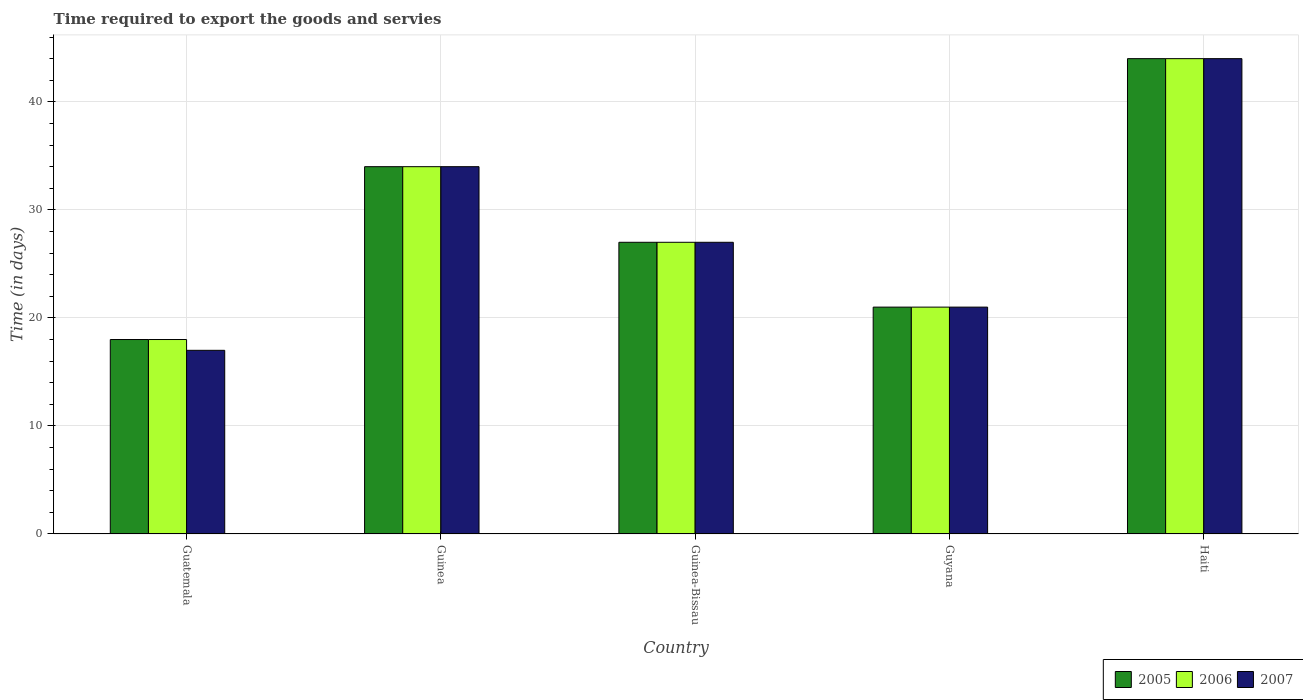How many different coloured bars are there?
Provide a succinct answer. 3. Are the number of bars on each tick of the X-axis equal?
Ensure brevity in your answer.  Yes. How many bars are there on the 1st tick from the left?
Ensure brevity in your answer.  3. What is the label of the 2nd group of bars from the left?
Keep it short and to the point. Guinea. In how many cases, is the number of bars for a given country not equal to the number of legend labels?
Give a very brief answer. 0. What is the number of days required to export the goods and services in 2007 in Guatemala?
Make the answer very short. 17. In which country was the number of days required to export the goods and services in 2007 maximum?
Your answer should be very brief. Haiti. In which country was the number of days required to export the goods and services in 2005 minimum?
Your answer should be compact. Guatemala. What is the total number of days required to export the goods and services in 2005 in the graph?
Offer a terse response. 144. What is the average number of days required to export the goods and services in 2007 per country?
Ensure brevity in your answer.  28.6. What is the difference between the number of days required to export the goods and services of/in 2007 and number of days required to export the goods and services of/in 2006 in Haiti?
Keep it short and to the point. 0. What is the ratio of the number of days required to export the goods and services in 2007 in Guatemala to that in Guyana?
Keep it short and to the point. 0.81. Is the number of days required to export the goods and services in 2007 in Guatemala less than that in Guyana?
Your response must be concise. Yes. Is the difference between the number of days required to export the goods and services in 2007 in Guatemala and Guyana greater than the difference between the number of days required to export the goods and services in 2006 in Guatemala and Guyana?
Offer a very short reply. No. What is the difference between the highest and the second highest number of days required to export the goods and services in 2005?
Offer a very short reply. 7. What is the difference between the highest and the lowest number of days required to export the goods and services in 2006?
Offer a very short reply. 26. In how many countries, is the number of days required to export the goods and services in 2006 greater than the average number of days required to export the goods and services in 2006 taken over all countries?
Ensure brevity in your answer.  2. Is the sum of the number of days required to export the goods and services in 2005 in Guinea and Guyana greater than the maximum number of days required to export the goods and services in 2007 across all countries?
Keep it short and to the point. Yes. Is it the case that in every country, the sum of the number of days required to export the goods and services in 2006 and number of days required to export the goods and services in 2005 is greater than the number of days required to export the goods and services in 2007?
Your response must be concise. Yes. Are all the bars in the graph horizontal?
Your response must be concise. No. Are the values on the major ticks of Y-axis written in scientific E-notation?
Keep it short and to the point. No. Where does the legend appear in the graph?
Your answer should be compact. Bottom right. What is the title of the graph?
Provide a succinct answer. Time required to export the goods and servies. What is the label or title of the X-axis?
Offer a very short reply. Country. What is the label or title of the Y-axis?
Give a very brief answer. Time (in days). What is the Time (in days) in 2006 in Guatemala?
Offer a very short reply. 18. What is the Time (in days) in 2006 in Guinea-Bissau?
Your answer should be compact. 27. What is the Time (in days) of 2007 in Guinea-Bissau?
Offer a very short reply. 27. What is the Time (in days) of 2005 in Guyana?
Your answer should be compact. 21. What is the Time (in days) of 2006 in Guyana?
Keep it short and to the point. 21. Across all countries, what is the maximum Time (in days) of 2005?
Offer a terse response. 44. Across all countries, what is the maximum Time (in days) of 2006?
Keep it short and to the point. 44. Across all countries, what is the minimum Time (in days) in 2007?
Your response must be concise. 17. What is the total Time (in days) of 2005 in the graph?
Provide a succinct answer. 144. What is the total Time (in days) of 2006 in the graph?
Provide a succinct answer. 144. What is the total Time (in days) of 2007 in the graph?
Provide a short and direct response. 143. What is the difference between the Time (in days) in 2006 in Guatemala and that in Guinea?
Your response must be concise. -16. What is the difference between the Time (in days) of 2006 in Guatemala and that in Guinea-Bissau?
Offer a terse response. -9. What is the difference between the Time (in days) of 2007 in Guatemala and that in Guinea-Bissau?
Provide a succinct answer. -10. What is the difference between the Time (in days) in 2005 in Guatemala and that in Guyana?
Your answer should be compact. -3. What is the difference between the Time (in days) of 2006 in Guatemala and that in Guyana?
Your response must be concise. -3. What is the difference between the Time (in days) in 2006 in Guatemala and that in Haiti?
Provide a succinct answer. -26. What is the difference between the Time (in days) in 2007 in Guatemala and that in Haiti?
Your answer should be very brief. -27. What is the difference between the Time (in days) in 2007 in Guinea and that in Guinea-Bissau?
Ensure brevity in your answer.  7. What is the difference between the Time (in days) of 2006 in Guinea and that in Guyana?
Keep it short and to the point. 13. What is the difference between the Time (in days) of 2006 in Guinea and that in Haiti?
Provide a succinct answer. -10. What is the difference between the Time (in days) in 2007 in Guinea and that in Haiti?
Ensure brevity in your answer.  -10. What is the difference between the Time (in days) of 2005 in Guyana and that in Haiti?
Your response must be concise. -23. What is the difference between the Time (in days) in 2007 in Guyana and that in Haiti?
Make the answer very short. -23. What is the difference between the Time (in days) of 2005 in Guatemala and the Time (in days) of 2006 in Guinea-Bissau?
Your response must be concise. -9. What is the difference between the Time (in days) in 2005 in Guatemala and the Time (in days) in 2007 in Guinea-Bissau?
Your response must be concise. -9. What is the difference between the Time (in days) in 2006 in Guatemala and the Time (in days) in 2007 in Guinea-Bissau?
Ensure brevity in your answer.  -9. What is the difference between the Time (in days) of 2005 in Guatemala and the Time (in days) of 2007 in Guyana?
Make the answer very short. -3. What is the difference between the Time (in days) in 2006 in Guatemala and the Time (in days) in 2007 in Guyana?
Your answer should be very brief. -3. What is the difference between the Time (in days) of 2005 in Guatemala and the Time (in days) of 2006 in Haiti?
Your response must be concise. -26. What is the difference between the Time (in days) in 2005 in Guatemala and the Time (in days) in 2007 in Haiti?
Keep it short and to the point. -26. What is the difference between the Time (in days) of 2006 in Guatemala and the Time (in days) of 2007 in Haiti?
Provide a succinct answer. -26. What is the difference between the Time (in days) of 2006 in Guinea and the Time (in days) of 2007 in Guyana?
Offer a very short reply. 13. What is the difference between the Time (in days) in 2005 in Guinea and the Time (in days) in 2006 in Haiti?
Ensure brevity in your answer.  -10. What is the difference between the Time (in days) of 2005 in Guinea-Bissau and the Time (in days) of 2007 in Guyana?
Ensure brevity in your answer.  6. What is the difference between the Time (in days) of 2005 in Guinea-Bissau and the Time (in days) of 2006 in Haiti?
Make the answer very short. -17. What is the average Time (in days) of 2005 per country?
Provide a short and direct response. 28.8. What is the average Time (in days) of 2006 per country?
Keep it short and to the point. 28.8. What is the average Time (in days) of 2007 per country?
Offer a terse response. 28.6. What is the difference between the Time (in days) in 2005 and Time (in days) in 2006 in Guinea?
Make the answer very short. 0. What is the difference between the Time (in days) of 2006 and Time (in days) of 2007 in Guinea?
Keep it short and to the point. 0. What is the difference between the Time (in days) of 2005 and Time (in days) of 2006 in Guinea-Bissau?
Offer a very short reply. 0. What is the difference between the Time (in days) in 2006 and Time (in days) in 2007 in Guinea-Bissau?
Ensure brevity in your answer.  0. What is the difference between the Time (in days) of 2005 and Time (in days) of 2006 in Haiti?
Provide a short and direct response. 0. What is the difference between the Time (in days) in 2005 and Time (in days) in 2007 in Haiti?
Make the answer very short. 0. What is the ratio of the Time (in days) in 2005 in Guatemala to that in Guinea?
Give a very brief answer. 0.53. What is the ratio of the Time (in days) of 2006 in Guatemala to that in Guinea?
Offer a very short reply. 0.53. What is the ratio of the Time (in days) in 2005 in Guatemala to that in Guinea-Bissau?
Provide a short and direct response. 0.67. What is the ratio of the Time (in days) in 2006 in Guatemala to that in Guinea-Bissau?
Give a very brief answer. 0.67. What is the ratio of the Time (in days) of 2007 in Guatemala to that in Guinea-Bissau?
Keep it short and to the point. 0.63. What is the ratio of the Time (in days) in 2007 in Guatemala to that in Guyana?
Offer a terse response. 0.81. What is the ratio of the Time (in days) of 2005 in Guatemala to that in Haiti?
Keep it short and to the point. 0.41. What is the ratio of the Time (in days) of 2006 in Guatemala to that in Haiti?
Your answer should be very brief. 0.41. What is the ratio of the Time (in days) in 2007 in Guatemala to that in Haiti?
Offer a terse response. 0.39. What is the ratio of the Time (in days) of 2005 in Guinea to that in Guinea-Bissau?
Ensure brevity in your answer.  1.26. What is the ratio of the Time (in days) of 2006 in Guinea to that in Guinea-Bissau?
Your answer should be compact. 1.26. What is the ratio of the Time (in days) of 2007 in Guinea to that in Guinea-Bissau?
Keep it short and to the point. 1.26. What is the ratio of the Time (in days) of 2005 in Guinea to that in Guyana?
Offer a very short reply. 1.62. What is the ratio of the Time (in days) of 2006 in Guinea to that in Guyana?
Keep it short and to the point. 1.62. What is the ratio of the Time (in days) in 2007 in Guinea to that in Guyana?
Provide a short and direct response. 1.62. What is the ratio of the Time (in days) in 2005 in Guinea to that in Haiti?
Ensure brevity in your answer.  0.77. What is the ratio of the Time (in days) of 2006 in Guinea to that in Haiti?
Offer a very short reply. 0.77. What is the ratio of the Time (in days) of 2007 in Guinea to that in Haiti?
Provide a short and direct response. 0.77. What is the ratio of the Time (in days) in 2005 in Guinea-Bissau to that in Guyana?
Offer a very short reply. 1.29. What is the ratio of the Time (in days) of 2006 in Guinea-Bissau to that in Guyana?
Ensure brevity in your answer.  1.29. What is the ratio of the Time (in days) of 2007 in Guinea-Bissau to that in Guyana?
Provide a succinct answer. 1.29. What is the ratio of the Time (in days) of 2005 in Guinea-Bissau to that in Haiti?
Offer a very short reply. 0.61. What is the ratio of the Time (in days) of 2006 in Guinea-Bissau to that in Haiti?
Make the answer very short. 0.61. What is the ratio of the Time (in days) of 2007 in Guinea-Bissau to that in Haiti?
Your answer should be compact. 0.61. What is the ratio of the Time (in days) in 2005 in Guyana to that in Haiti?
Offer a terse response. 0.48. What is the ratio of the Time (in days) of 2006 in Guyana to that in Haiti?
Your answer should be compact. 0.48. What is the ratio of the Time (in days) in 2007 in Guyana to that in Haiti?
Provide a succinct answer. 0.48. What is the difference between the highest and the second highest Time (in days) in 2005?
Offer a terse response. 10. What is the difference between the highest and the second highest Time (in days) of 2006?
Your answer should be very brief. 10. What is the difference between the highest and the second highest Time (in days) of 2007?
Offer a terse response. 10. 